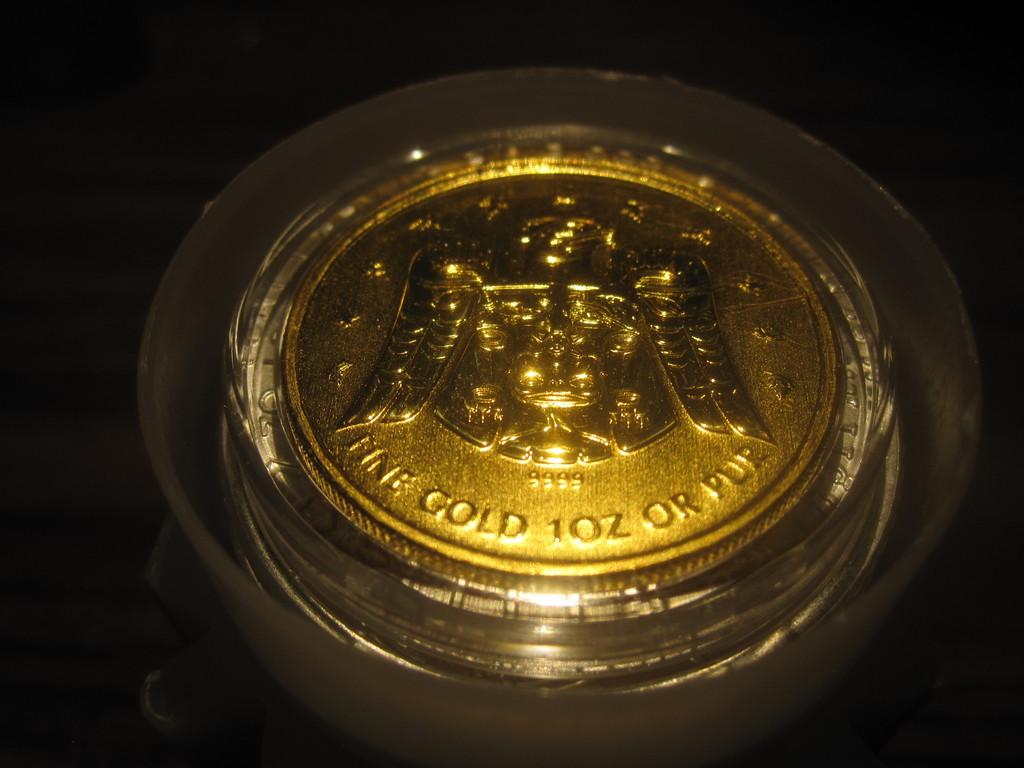<image>
Share a concise interpretation of the image provided. A 1 ounce gold coin is displayed in a small case. 